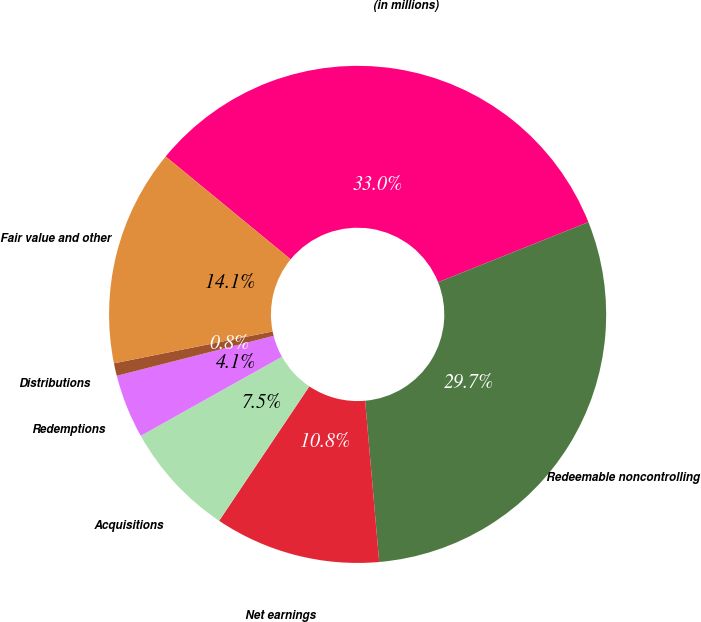Convert chart to OTSL. <chart><loc_0><loc_0><loc_500><loc_500><pie_chart><fcel>(in millions)<fcel>Redeemable noncontrolling<fcel>Net earnings<fcel>Acquisitions<fcel>Redemptions<fcel>Distributions<fcel>Fair value and other<nl><fcel>32.99%<fcel>29.67%<fcel>10.79%<fcel>7.47%<fcel>4.15%<fcel>0.82%<fcel>14.11%<nl></chart> 